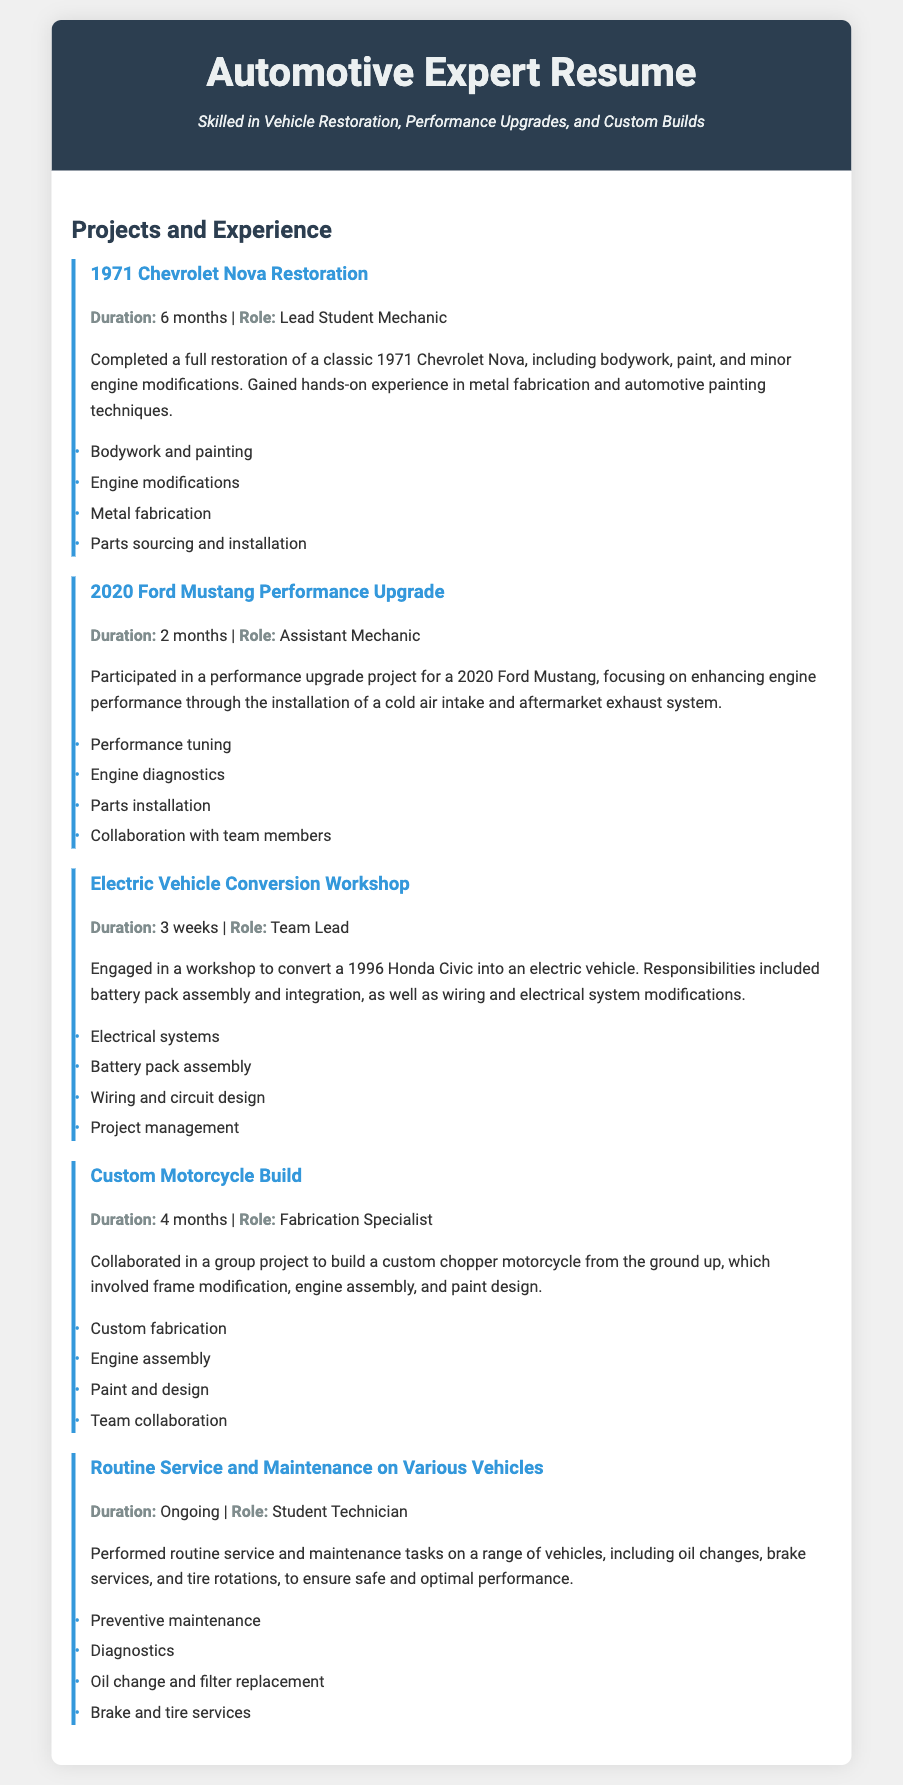What vehicle was restored in the first project? The first project mentions a 1971 Chevrolet Nova which was fully restored during the training.
Answer: 1971 Chevrolet Nova How long did the 2020 Ford Mustang performance upgrade take? The duration for the performance upgrade project on the 2020 Ford Mustang is stated as 2 months.
Answer: 2 months What role did the individual have in the Electric Vehicle Conversion Workshop? The document identifies the individual as the Team Lead for the Electric Vehicle Conversion Workshop.
Answer: Team Lead What main tasks were performed during the maintenance of various vehicles? The document lists preventive maintenance, diagnostics, oil change, and brake services as key tasks performed.
Answer: Preventive maintenance What type of vehicle was the custom motorcycle built from? The custom motorcycle project involved building a chopper motorcycle from the ground up, as mentioned in the document.
Answer: Chopper motorcycle In which project was battery pack assembly a responsibility? The project involving battery pack assembly is the Electric Vehicle Conversion Workshop where a 1996 Honda Civic was converted.
Answer: Electric Vehicle Conversion Workshop Which project involved collaboration with team members? The 2020 Ford Mustang Performance Upgrade project included collaboration with team members for enhancing engine performance.
Answer: 2020 Ford Mustang Performance Upgrade What was a significant skill learned during the 1971 Chevrolet Nova Restoration? The restoration process allowed the individual to gain hands-on experience in metal fabrication as one of the listed skills.
Answer: Metal fabrication 